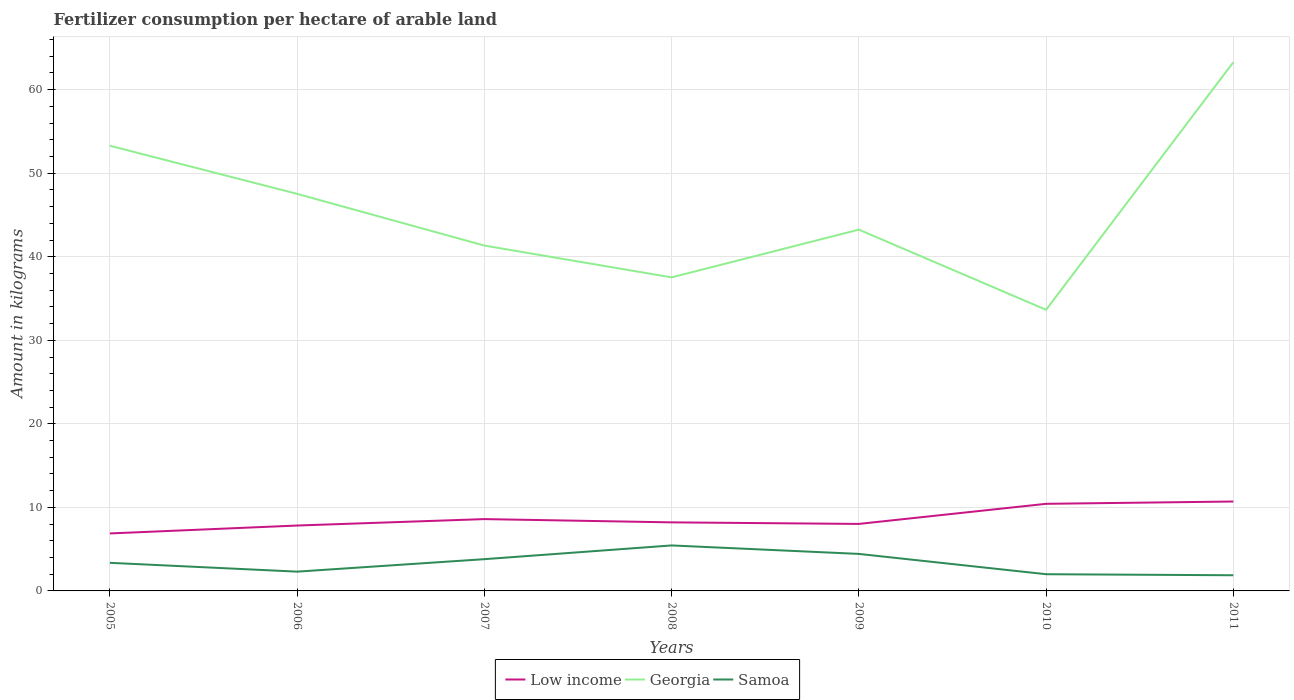How many different coloured lines are there?
Your answer should be compact. 3. Is the number of lines equal to the number of legend labels?
Make the answer very short. Yes. Across all years, what is the maximum amount of fertilizer consumption in Low income?
Your answer should be compact. 6.88. What is the total amount of fertilizer consumption in Low income in the graph?
Offer a terse response. -1.33. What is the difference between the highest and the second highest amount of fertilizer consumption in Samoa?
Provide a succinct answer. 3.57. What is the difference between the highest and the lowest amount of fertilizer consumption in Georgia?
Your answer should be compact. 3. Is the amount of fertilizer consumption in Low income strictly greater than the amount of fertilizer consumption in Samoa over the years?
Provide a short and direct response. No. What is the difference between two consecutive major ticks on the Y-axis?
Your answer should be very brief. 10. Does the graph contain any zero values?
Offer a very short reply. No. How many legend labels are there?
Keep it short and to the point. 3. What is the title of the graph?
Keep it short and to the point. Fertilizer consumption per hectare of arable land. What is the label or title of the Y-axis?
Provide a succinct answer. Amount in kilograms. What is the Amount in kilograms in Low income in 2005?
Your response must be concise. 6.88. What is the Amount in kilograms of Georgia in 2005?
Offer a very short reply. 53.29. What is the Amount in kilograms of Samoa in 2005?
Make the answer very short. 3.36. What is the Amount in kilograms of Low income in 2006?
Give a very brief answer. 7.83. What is the Amount in kilograms of Georgia in 2006?
Provide a short and direct response. 47.53. What is the Amount in kilograms in Samoa in 2006?
Give a very brief answer. 2.31. What is the Amount in kilograms of Low income in 2007?
Offer a very short reply. 8.6. What is the Amount in kilograms in Georgia in 2007?
Provide a short and direct response. 41.34. What is the Amount in kilograms in Low income in 2008?
Your answer should be compact. 8.21. What is the Amount in kilograms in Georgia in 2008?
Keep it short and to the point. 37.53. What is the Amount in kilograms in Samoa in 2008?
Keep it short and to the point. 5.44. What is the Amount in kilograms in Low income in 2009?
Provide a short and direct response. 8.02. What is the Amount in kilograms in Georgia in 2009?
Give a very brief answer. 43.25. What is the Amount in kilograms in Samoa in 2009?
Keep it short and to the point. 4.43. What is the Amount in kilograms of Low income in 2010?
Make the answer very short. 10.43. What is the Amount in kilograms in Georgia in 2010?
Keep it short and to the point. 33.65. What is the Amount in kilograms of Low income in 2011?
Ensure brevity in your answer.  10.7. What is the Amount in kilograms in Georgia in 2011?
Your answer should be compact. 63.29. What is the Amount in kilograms in Samoa in 2011?
Make the answer very short. 1.88. Across all years, what is the maximum Amount in kilograms of Low income?
Your response must be concise. 10.7. Across all years, what is the maximum Amount in kilograms in Georgia?
Provide a succinct answer. 63.29. Across all years, what is the maximum Amount in kilograms in Samoa?
Your answer should be very brief. 5.44. Across all years, what is the minimum Amount in kilograms in Low income?
Provide a succinct answer. 6.88. Across all years, what is the minimum Amount in kilograms of Georgia?
Your answer should be compact. 33.65. Across all years, what is the minimum Amount in kilograms of Samoa?
Provide a short and direct response. 1.88. What is the total Amount in kilograms in Low income in the graph?
Ensure brevity in your answer.  60.66. What is the total Amount in kilograms of Georgia in the graph?
Provide a succinct answer. 319.87. What is the total Amount in kilograms of Samoa in the graph?
Offer a terse response. 23.22. What is the difference between the Amount in kilograms in Low income in 2005 and that in 2006?
Provide a succinct answer. -0.95. What is the difference between the Amount in kilograms in Georgia in 2005 and that in 2006?
Provide a succinct answer. 5.76. What is the difference between the Amount in kilograms of Samoa in 2005 and that in 2006?
Your answer should be very brief. 1.06. What is the difference between the Amount in kilograms of Low income in 2005 and that in 2007?
Provide a succinct answer. -1.72. What is the difference between the Amount in kilograms of Georgia in 2005 and that in 2007?
Make the answer very short. 11.95. What is the difference between the Amount in kilograms of Samoa in 2005 and that in 2007?
Keep it short and to the point. -0.44. What is the difference between the Amount in kilograms of Low income in 2005 and that in 2008?
Ensure brevity in your answer.  -1.33. What is the difference between the Amount in kilograms in Georgia in 2005 and that in 2008?
Ensure brevity in your answer.  15.76. What is the difference between the Amount in kilograms in Samoa in 2005 and that in 2008?
Make the answer very short. -2.08. What is the difference between the Amount in kilograms in Low income in 2005 and that in 2009?
Offer a terse response. -1.14. What is the difference between the Amount in kilograms in Georgia in 2005 and that in 2009?
Offer a terse response. 10.04. What is the difference between the Amount in kilograms of Samoa in 2005 and that in 2009?
Your answer should be compact. -1.07. What is the difference between the Amount in kilograms of Low income in 2005 and that in 2010?
Keep it short and to the point. -3.54. What is the difference between the Amount in kilograms in Georgia in 2005 and that in 2010?
Your answer should be very brief. 19.63. What is the difference between the Amount in kilograms of Samoa in 2005 and that in 2010?
Your answer should be compact. 1.36. What is the difference between the Amount in kilograms of Low income in 2005 and that in 2011?
Provide a succinct answer. -3.82. What is the difference between the Amount in kilograms in Georgia in 2005 and that in 2011?
Your response must be concise. -10. What is the difference between the Amount in kilograms of Samoa in 2005 and that in 2011?
Provide a short and direct response. 1.49. What is the difference between the Amount in kilograms of Low income in 2006 and that in 2007?
Your response must be concise. -0.77. What is the difference between the Amount in kilograms of Georgia in 2006 and that in 2007?
Your answer should be compact. 6.19. What is the difference between the Amount in kilograms in Samoa in 2006 and that in 2007?
Provide a short and direct response. -1.49. What is the difference between the Amount in kilograms of Low income in 2006 and that in 2008?
Your answer should be very brief. -0.38. What is the difference between the Amount in kilograms of Georgia in 2006 and that in 2008?
Give a very brief answer. 10. What is the difference between the Amount in kilograms of Samoa in 2006 and that in 2008?
Ensure brevity in your answer.  -3.14. What is the difference between the Amount in kilograms in Low income in 2006 and that in 2009?
Offer a very short reply. -0.19. What is the difference between the Amount in kilograms in Georgia in 2006 and that in 2009?
Offer a very short reply. 4.28. What is the difference between the Amount in kilograms of Samoa in 2006 and that in 2009?
Your response must be concise. -2.12. What is the difference between the Amount in kilograms of Low income in 2006 and that in 2010?
Offer a very short reply. -2.6. What is the difference between the Amount in kilograms in Georgia in 2006 and that in 2010?
Your answer should be compact. 13.88. What is the difference between the Amount in kilograms in Samoa in 2006 and that in 2010?
Your answer should be very brief. 0.31. What is the difference between the Amount in kilograms of Low income in 2006 and that in 2011?
Give a very brief answer. -2.87. What is the difference between the Amount in kilograms in Georgia in 2006 and that in 2011?
Ensure brevity in your answer.  -15.76. What is the difference between the Amount in kilograms of Samoa in 2006 and that in 2011?
Make the answer very short. 0.43. What is the difference between the Amount in kilograms in Low income in 2007 and that in 2008?
Provide a succinct answer. 0.39. What is the difference between the Amount in kilograms of Georgia in 2007 and that in 2008?
Make the answer very short. 3.81. What is the difference between the Amount in kilograms of Samoa in 2007 and that in 2008?
Your answer should be very brief. -1.64. What is the difference between the Amount in kilograms in Low income in 2007 and that in 2009?
Keep it short and to the point. 0.58. What is the difference between the Amount in kilograms in Georgia in 2007 and that in 2009?
Offer a terse response. -1.91. What is the difference between the Amount in kilograms of Samoa in 2007 and that in 2009?
Ensure brevity in your answer.  -0.63. What is the difference between the Amount in kilograms in Low income in 2007 and that in 2010?
Your response must be concise. -1.83. What is the difference between the Amount in kilograms in Georgia in 2007 and that in 2010?
Provide a succinct answer. 7.69. What is the difference between the Amount in kilograms in Samoa in 2007 and that in 2010?
Make the answer very short. 1.8. What is the difference between the Amount in kilograms in Low income in 2007 and that in 2011?
Your answer should be compact. -2.1. What is the difference between the Amount in kilograms in Georgia in 2007 and that in 2011?
Offer a very short reply. -21.95. What is the difference between the Amount in kilograms in Samoa in 2007 and that in 2011?
Offer a terse response. 1.93. What is the difference between the Amount in kilograms in Low income in 2008 and that in 2009?
Offer a very short reply. 0.19. What is the difference between the Amount in kilograms of Georgia in 2008 and that in 2009?
Give a very brief answer. -5.72. What is the difference between the Amount in kilograms in Samoa in 2008 and that in 2009?
Your response must be concise. 1.01. What is the difference between the Amount in kilograms in Low income in 2008 and that in 2010?
Ensure brevity in your answer.  -2.22. What is the difference between the Amount in kilograms of Georgia in 2008 and that in 2010?
Your answer should be compact. 3.88. What is the difference between the Amount in kilograms of Samoa in 2008 and that in 2010?
Your answer should be very brief. 3.44. What is the difference between the Amount in kilograms in Low income in 2008 and that in 2011?
Ensure brevity in your answer.  -2.49. What is the difference between the Amount in kilograms of Georgia in 2008 and that in 2011?
Your answer should be compact. -25.75. What is the difference between the Amount in kilograms in Samoa in 2008 and that in 2011?
Keep it short and to the point. 3.57. What is the difference between the Amount in kilograms in Low income in 2009 and that in 2010?
Your response must be concise. -2.41. What is the difference between the Amount in kilograms in Georgia in 2009 and that in 2010?
Keep it short and to the point. 9.59. What is the difference between the Amount in kilograms in Samoa in 2009 and that in 2010?
Your answer should be very brief. 2.43. What is the difference between the Amount in kilograms of Low income in 2009 and that in 2011?
Provide a succinct answer. -2.68. What is the difference between the Amount in kilograms of Georgia in 2009 and that in 2011?
Your response must be concise. -20.04. What is the difference between the Amount in kilograms of Samoa in 2009 and that in 2011?
Your answer should be compact. 2.56. What is the difference between the Amount in kilograms of Low income in 2010 and that in 2011?
Provide a succinct answer. -0.28. What is the difference between the Amount in kilograms in Georgia in 2010 and that in 2011?
Offer a very short reply. -29.63. What is the difference between the Amount in kilograms of Low income in 2005 and the Amount in kilograms of Georgia in 2006?
Offer a very short reply. -40.65. What is the difference between the Amount in kilograms of Low income in 2005 and the Amount in kilograms of Samoa in 2006?
Keep it short and to the point. 4.57. What is the difference between the Amount in kilograms of Georgia in 2005 and the Amount in kilograms of Samoa in 2006?
Your answer should be compact. 50.98. What is the difference between the Amount in kilograms in Low income in 2005 and the Amount in kilograms in Georgia in 2007?
Your answer should be very brief. -34.46. What is the difference between the Amount in kilograms of Low income in 2005 and the Amount in kilograms of Samoa in 2007?
Provide a succinct answer. 3.08. What is the difference between the Amount in kilograms in Georgia in 2005 and the Amount in kilograms in Samoa in 2007?
Your answer should be compact. 49.49. What is the difference between the Amount in kilograms in Low income in 2005 and the Amount in kilograms in Georgia in 2008?
Your answer should be compact. -30.65. What is the difference between the Amount in kilograms of Low income in 2005 and the Amount in kilograms of Samoa in 2008?
Give a very brief answer. 1.44. What is the difference between the Amount in kilograms in Georgia in 2005 and the Amount in kilograms in Samoa in 2008?
Your answer should be very brief. 47.84. What is the difference between the Amount in kilograms of Low income in 2005 and the Amount in kilograms of Georgia in 2009?
Ensure brevity in your answer.  -36.37. What is the difference between the Amount in kilograms of Low income in 2005 and the Amount in kilograms of Samoa in 2009?
Keep it short and to the point. 2.45. What is the difference between the Amount in kilograms of Georgia in 2005 and the Amount in kilograms of Samoa in 2009?
Your answer should be very brief. 48.86. What is the difference between the Amount in kilograms of Low income in 2005 and the Amount in kilograms of Georgia in 2010?
Your answer should be very brief. -26.77. What is the difference between the Amount in kilograms of Low income in 2005 and the Amount in kilograms of Samoa in 2010?
Your response must be concise. 4.88. What is the difference between the Amount in kilograms in Georgia in 2005 and the Amount in kilograms in Samoa in 2010?
Offer a terse response. 51.29. What is the difference between the Amount in kilograms of Low income in 2005 and the Amount in kilograms of Georgia in 2011?
Your response must be concise. -56.4. What is the difference between the Amount in kilograms of Low income in 2005 and the Amount in kilograms of Samoa in 2011?
Your answer should be compact. 5.01. What is the difference between the Amount in kilograms of Georgia in 2005 and the Amount in kilograms of Samoa in 2011?
Ensure brevity in your answer.  51.41. What is the difference between the Amount in kilograms of Low income in 2006 and the Amount in kilograms of Georgia in 2007?
Offer a terse response. -33.51. What is the difference between the Amount in kilograms of Low income in 2006 and the Amount in kilograms of Samoa in 2007?
Keep it short and to the point. 4.03. What is the difference between the Amount in kilograms of Georgia in 2006 and the Amount in kilograms of Samoa in 2007?
Your response must be concise. 43.73. What is the difference between the Amount in kilograms of Low income in 2006 and the Amount in kilograms of Georgia in 2008?
Your answer should be very brief. -29.7. What is the difference between the Amount in kilograms in Low income in 2006 and the Amount in kilograms in Samoa in 2008?
Offer a very short reply. 2.38. What is the difference between the Amount in kilograms in Georgia in 2006 and the Amount in kilograms in Samoa in 2008?
Your answer should be compact. 42.08. What is the difference between the Amount in kilograms of Low income in 2006 and the Amount in kilograms of Georgia in 2009?
Make the answer very short. -35.42. What is the difference between the Amount in kilograms of Low income in 2006 and the Amount in kilograms of Samoa in 2009?
Provide a succinct answer. 3.4. What is the difference between the Amount in kilograms in Georgia in 2006 and the Amount in kilograms in Samoa in 2009?
Make the answer very short. 43.1. What is the difference between the Amount in kilograms in Low income in 2006 and the Amount in kilograms in Georgia in 2010?
Offer a very short reply. -25.83. What is the difference between the Amount in kilograms in Low income in 2006 and the Amount in kilograms in Samoa in 2010?
Ensure brevity in your answer.  5.83. What is the difference between the Amount in kilograms in Georgia in 2006 and the Amount in kilograms in Samoa in 2010?
Ensure brevity in your answer.  45.53. What is the difference between the Amount in kilograms of Low income in 2006 and the Amount in kilograms of Georgia in 2011?
Offer a terse response. -55.46. What is the difference between the Amount in kilograms in Low income in 2006 and the Amount in kilograms in Samoa in 2011?
Offer a very short reply. 5.95. What is the difference between the Amount in kilograms of Georgia in 2006 and the Amount in kilograms of Samoa in 2011?
Make the answer very short. 45.65. What is the difference between the Amount in kilograms of Low income in 2007 and the Amount in kilograms of Georgia in 2008?
Your answer should be very brief. -28.93. What is the difference between the Amount in kilograms of Low income in 2007 and the Amount in kilograms of Samoa in 2008?
Provide a short and direct response. 3.15. What is the difference between the Amount in kilograms of Georgia in 2007 and the Amount in kilograms of Samoa in 2008?
Provide a short and direct response. 35.89. What is the difference between the Amount in kilograms of Low income in 2007 and the Amount in kilograms of Georgia in 2009?
Make the answer very short. -34.65. What is the difference between the Amount in kilograms of Low income in 2007 and the Amount in kilograms of Samoa in 2009?
Your response must be concise. 4.17. What is the difference between the Amount in kilograms in Georgia in 2007 and the Amount in kilograms in Samoa in 2009?
Give a very brief answer. 36.91. What is the difference between the Amount in kilograms of Low income in 2007 and the Amount in kilograms of Georgia in 2010?
Make the answer very short. -25.06. What is the difference between the Amount in kilograms of Low income in 2007 and the Amount in kilograms of Samoa in 2010?
Your answer should be compact. 6.6. What is the difference between the Amount in kilograms in Georgia in 2007 and the Amount in kilograms in Samoa in 2010?
Your answer should be very brief. 39.34. What is the difference between the Amount in kilograms in Low income in 2007 and the Amount in kilograms in Georgia in 2011?
Your answer should be compact. -54.69. What is the difference between the Amount in kilograms in Low income in 2007 and the Amount in kilograms in Samoa in 2011?
Provide a succinct answer. 6.72. What is the difference between the Amount in kilograms of Georgia in 2007 and the Amount in kilograms of Samoa in 2011?
Your response must be concise. 39.46. What is the difference between the Amount in kilograms of Low income in 2008 and the Amount in kilograms of Georgia in 2009?
Give a very brief answer. -35.04. What is the difference between the Amount in kilograms of Low income in 2008 and the Amount in kilograms of Samoa in 2009?
Make the answer very short. 3.78. What is the difference between the Amount in kilograms of Georgia in 2008 and the Amount in kilograms of Samoa in 2009?
Your answer should be compact. 33.1. What is the difference between the Amount in kilograms of Low income in 2008 and the Amount in kilograms of Georgia in 2010?
Provide a succinct answer. -25.45. What is the difference between the Amount in kilograms of Low income in 2008 and the Amount in kilograms of Samoa in 2010?
Your answer should be compact. 6.21. What is the difference between the Amount in kilograms of Georgia in 2008 and the Amount in kilograms of Samoa in 2010?
Give a very brief answer. 35.53. What is the difference between the Amount in kilograms of Low income in 2008 and the Amount in kilograms of Georgia in 2011?
Ensure brevity in your answer.  -55.08. What is the difference between the Amount in kilograms in Low income in 2008 and the Amount in kilograms in Samoa in 2011?
Your answer should be compact. 6.33. What is the difference between the Amount in kilograms in Georgia in 2008 and the Amount in kilograms in Samoa in 2011?
Offer a terse response. 35.66. What is the difference between the Amount in kilograms in Low income in 2009 and the Amount in kilograms in Georgia in 2010?
Provide a succinct answer. -25.63. What is the difference between the Amount in kilograms in Low income in 2009 and the Amount in kilograms in Samoa in 2010?
Keep it short and to the point. 6.02. What is the difference between the Amount in kilograms in Georgia in 2009 and the Amount in kilograms in Samoa in 2010?
Offer a very short reply. 41.25. What is the difference between the Amount in kilograms in Low income in 2009 and the Amount in kilograms in Georgia in 2011?
Give a very brief answer. -55.26. What is the difference between the Amount in kilograms of Low income in 2009 and the Amount in kilograms of Samoa in 2011?
Your answer should be very brief. 6.15. What is the difference between the Amount in kilograms in Georgia in 2009 and the Amount in kilograms in Samoa in 2011?
Provide a short and direct response. 41.37. What is the difference between the Amount in kilograms in Low income in 2010 and the Amount in kilograms in Georgia in 2011?
Keep it short and to the point. -52.86. What is the difference between the Amount in kilograms of Low income in 2010 and the Amount in kilograms of Samoa in 2011?
Ensure brevity in your answer.  8.55. What is the difference between the Amount in kilograms in Georgia in 2010 and the Amount in kilograms in Samoa in 2011?
Your answer should be compact. 31.78. What is the average Amount in kilograms in Low income per year?
Your answer should be compact. 8.67. What is the average Amount in kilograms of Georgia per year?
Your answer should be very brief. 45.7. What is the average Amount in kilograms of Samoa per year?
Your response must be concise. 3.32. In the year 2005, what is the difference between the Amount in kilograms in Low income and Amount in kilograms in Georgia?
Give a very brief answer. -46.41. In the year 2005, what is the difference between the Amount in kilograms in Low income and Amount in kilograms in Samoa?
Your answer should be compact. 3.52. In the year 2005, what is the difference between the Amount in kilograms of Georgia and Amount in kilograms of Samoa?
Ensure brevity in your answer.  49.92. In the year 2006, what is the difference between the Amount in kilograms in Low income and Amount in kilograms in Georgia?
Your answer should be very brief. -39.7. In the year 2006, what is the difference between the Amount in kilograms in Low income and Amount in kilograms in Samoa?
Your answer should be very brief. 5.52. In the year 2006, what is the difference between the Amount in kilograms of Georgia and Amount in kilograms of Samoa?
Ensure brevity in your answer.  45.22. In the year 2007, what is the difference between the Amount in kilograms in Low income and Amount in kilograms in Georgia?
Make the answer very short. -32.74. In the year 2007, what is the difference between the Amount in kilograms of Low income and Amount in kilograms of Samoa?
Make the answer very short. 4.8. In the year 2007, what is the difference between the Amount in kilograms in Georgia and Amount in kilograms in Samoa?
Keep it short and to the point. 37.54. In the year 2008, what is the difference between the Amount in kilograms in Low income and Amount in kilograms in Georgia?
Make the answer very short. -29.32. In the year 2008, what is the difference between the Amount in kilograms of Low income and Amount in kilograms of Samoa?
Provide a short and direct response. 2.76. In the year 2008, what is the difference between the Amount in kilograms in Georgia and Amount in kilograms in Samoa?
Make the answer very short. 32.09. In the year 2009, what is the difference between the Amount in kilograms of Low income and Amount in kilograms of Georgia?
Provide a succinct answer. -35.23. In the year 2009, what is the difference between the Amount in kilograms in Low income and Amount in kilograms in Samoa?
Your answer should be very brief. 3.59. In the year 2009, what is the difference between the Amount in kilograms in Georgia and Amount in kilograms in Samoa?
Offer a very short reply. 38.82. In the year 2010, what is the difference between the Amount in kilograms in Low income and Amount in kilograms in Georgia?
Ensure brevity in your answer.  -23.23. In the year 2010, what is the difference between the Amount in kilograms of Low income and Amount in kilograms of Samoa?
Your response must be concise. 8.43. In the year 2010, what is the difference between the Amount in kilograms in Georgia and Amount in kilograms in Samoa?
Provide a succinct answer. 31.65. In the year 2011, what is the difference between the Amount in kilograms of Low income and Amount in kilograms of Georgia?
Offer a terse response. -52.58. In the year 2011, what is the difference between the Amount in kilograms of Low income and Amount in kilograms of Samoa?
Ensure brevity in your answer.  8.83. In the year 2011, what is the difference between the Amount in kilograms of Georgia and Amount in kilograms of Samoa?
Provide a short and direct response. 61.41. What is the ratio of the Amount in kilograms of Low income in 2005 to that in 2006?
Give a very brief answer. 0.88. What is the ratio of the Amount in kilograms of Georgia in 2005 to that in 2006?
Make the answer very short. 1.12. What is the ratio of the Amount in kilograms in Samoa in 2005 to that in 2006?
Your answer should be very brief. 1.46. What is the ratio of the Amount in kilograms of Low income in 2005 to that in 2007?
Offer a very short reply. 0.8. What is the ratio of the Amount in kilograms in Georgia in 2005 to that in 2007?
Provide a succinct answer. 1.29. What is the ratio of the Amount in kilograms of Samoa in 2005 to that in 2007?
Keep it short and to the point. 0.89. What is the ratio of the Amount in kilograms in Low income in 2005 to that in 2008?
Give a very brief answer. 0.84. What is the ratio of the Amount in kilograms in Georgia in 2005 to that in 2008?
Your response must be concise. 1.42. What is the ratio of the Amount in kilograms in Samoa in 2005 to that in 2008?
Keep it short and to the point. 0.62. What is the ratio of the Amount in kilograms in Low income in 2005 to that in 2009?
Ensure brevity in your answer.  0.86. What is the ratio of the Amount in kilograms in Georgia in 2005 to that in 2009?
Ensure brevity in your answer.  1.23. What is the ratio of the Amount in kilograms in Samoa in 2005 to that in 2009?
Ensure brevity in your answer.  0.76. What is the ratio of the Amount in kilograms in Low income in 2005 to that in 2010?
Make the answer very short. 0.66. What is the ratio of the Amount in kilograms in Georgia in 2005 to that in 2010?
Your answer should be very brief. 1.58. What is the ratio of the Amount in kilograms of Samoa in 2005 to that in 2010?
Offer a very short reply. 1.68. What is the ratio of the Amount in kilograms in Low income in 2005 to that in 2011?
Your response must be concise. 0.64. What is the ratio of the Amount in kilograms of Georgia in 2005 to that in 2011?
Give a very brief answer. 0.84. What is the ratio of the Amount in kilograms in Samoa in 2005 to that in 2011?
Make the answer very short. 1.79. What is the ratio of the Amount in kilograms in Low income in 2006 to that in 2007?
Your answer should be very brief. 0.91. What is the ratio of the Amount in kilograms in Georgia in 2006 to that in 2007?
Ensure brevity in your answer.  1.15. What is the ratio of the Amount in kilograms in Samoa in 2006 to that in 2007?
Ensure brevity in your answer.  0.61. What is the ratio of the Amount in kilograms in Low income in 2006 to that in 2008?
Provide a succinct answer. 0.95. What is the ratio of the Amount in kilograms of Georgia in 2006 to that in 2008?
Your response must be concise. 1.27. What is the ratio of the Amount in kilograms in Samoa in 2006 to that in 2008?
Make the answer very short. 0.42. What is the ratio of the Amount in kilograms of Low income in 2006 to that in 2009?
Offer a very short reply. 0.98. What is the ratio of the Amount in kilograms of Georgia in 2006 to that in 2009?
Provide a short and direct response. 1.1. What is the ratio of the Amount in kilograms in Samoa in 2006 to that in 2009?
Provide a succinct answer. 0.52. What is the ratio of the Amount in kilograms of Low income in 2006 to that in 2010?
Your answer should be very brief. 0.75. What is the ratio of the Amount in kilograms in Georgia in 2006 to that in 2010?
Provide a short and direct response. 1.41. What is the ratio of the Amount in kilograms in Samoa in 2006 to that in 2010?
Provide a succinct answer. 1.15. What is the ratio of the Amount in kilograms in Low income in 2006 to that in 2011?
Your response must be concise. 0.73. What is the ratio of the Amount in kilograms of Georgia in 2006 to that in 2011?
Your answer should be compact. 0.75. What is the ratio of the Amount in kilograms of Samoa in 2006 to that in 2011?
Offer a very short reply. 1.23. What is the ratio of the Amount in kilograms of Low income in 2007 to that in 2008?
Offer a very short reply. 1.05. What is the ratio of the Amount in kilograms in Georgia in 2007 to that in 2008?
Ensure brevity in your answer.  1.1. What is the ratio of the Amount in kilograms in Samoa in 2007 to that in 2008?
Ensure brevity in your answer.  0.7. What is the ratio of the Amount in kilograms in Low income in 2007 to that in 2009?
Your answer should be very brief. 1.07. What is the ratio of the Amount in kilograms in Georgia in 2007 to that in 2009?
Your answer should be compact. 0.96. What is the ratio of the Amount in kilograms of Samoa in 2007 to that in 2009?
Keep it short and to the point. 0.86. What is the ratio of the Amount in kilograms of Low income in 2007 to that in 2010?
Provide a succinct answer. 0.82. What is the ratio of the Amount in kilograms in Georgia in 2007 to that in 2010?
Provide a short and direct response. 1.23. What is the ratio of the Amount in kilograms of Low income in 2007 to that in 2011?
Your answer should be very brief. 0.8. What is the ratio of the Amount in kilograms in Georgia in 2007 to that in 2011?
Your answer should be compact. 0.65. What is the ratio of the Amount in kilograms in Samoa in 2007 to that in 2011?
Provide a short and direct response. 2.03. What is the ratio of the Amount in kilograms in Low income in 2008 to that in 2009?
Provide a short and direct response. 1.02. What is the ratio of the Amount in kilograms in Georgia in 2008 to that in 2009?
Your answer should be very brief. 0.87. What is the ratio of the Amount in kilograms in Samoa in 2008 to that in 2009?
Your response must be concise. 1.23. What is the ratio of the Amount in kilograms in Low income in 2008 to that in 2010?
Offer a terse response. 0.79. What is the ratio of the Amount in kilograms of Georgia in 2008 to that in 2010?
Your response must be concise. 1.12. What is the ratio of the Amount in kilograms of Samoa in 2008 to that in 2010?
Your response must be concise. 2.72. What is the ratio of the Amount in kilograms of Low income in 2008 to that in 2011?
Provide a succinct answer. 0.77. What is the ratio of the Amount in kilograms in Georgia in 2008 to that in 2011?
Your response must be concise. 0.59. What is the ratio of the Amount in kilograms of Samoa in 2008 to that in 2011?
Provide a succinct answer. 2.9. What is the ratio of the Amount in kilograms in Low income in 2009 to that in 2010?
Your answer should be very brief. 0.77. What is the ratio of the Amount in kilograms in Georgia in 2009 to that in 2010?
Offer a terse response. 1.29. What is the ratio of the Amount in kilograms of Samoa in 2009 to that in 2010?
Give a very brief answer. 2.22. What is the ratio of the Amount in kilograms in Low income in 2009 to that in 2011?
Offer a very short reply. 0.75. What is the ratio of the Amount in kilograms of Georgia in 2009 to that in 2011?
Offer a very short reply. 0.68. What is the ratio of the Amount in kilograms in Samoa in 2009 to that in 2011?
Make the answer very short. 2.36. What is the ratio of the Amount in kilograms of Low income in 2010 to that in 2011?
Offer a terse response. 0.97. What is the ratio of the Amount in kilograms of Georgia in 2010 to that in 2011?
Your answer should be compact. 0.53. What is the ratio of the Amount in kilograms of Samoa in 2010 to that in 2011?
Keep it short and to the point. 1.07. What is the difference between the highest and the second highest Amount in kilograms of Low income?
Your response must be concise. 0.28. What is the difference between the highest and the second highest Amount in kilograms of Georgia?
Your answer should be compact. 10. What is the difference between the highest and the second highest Amount in kilograms of Samoa?
Your answer should be very brief. 1.01. What is the difference between the highest and the lowest Amount in kilograms in Low income?
Ensure brevity in your answer.  3.82. What is the difference between the highest and the lowest Amount in kilograms of Georgia?
Make the answer very short. 29.63. What is the difference between the highest and the lowest Amount in kilograms in Samoa?
Keep it short and to the point. 3.57. 